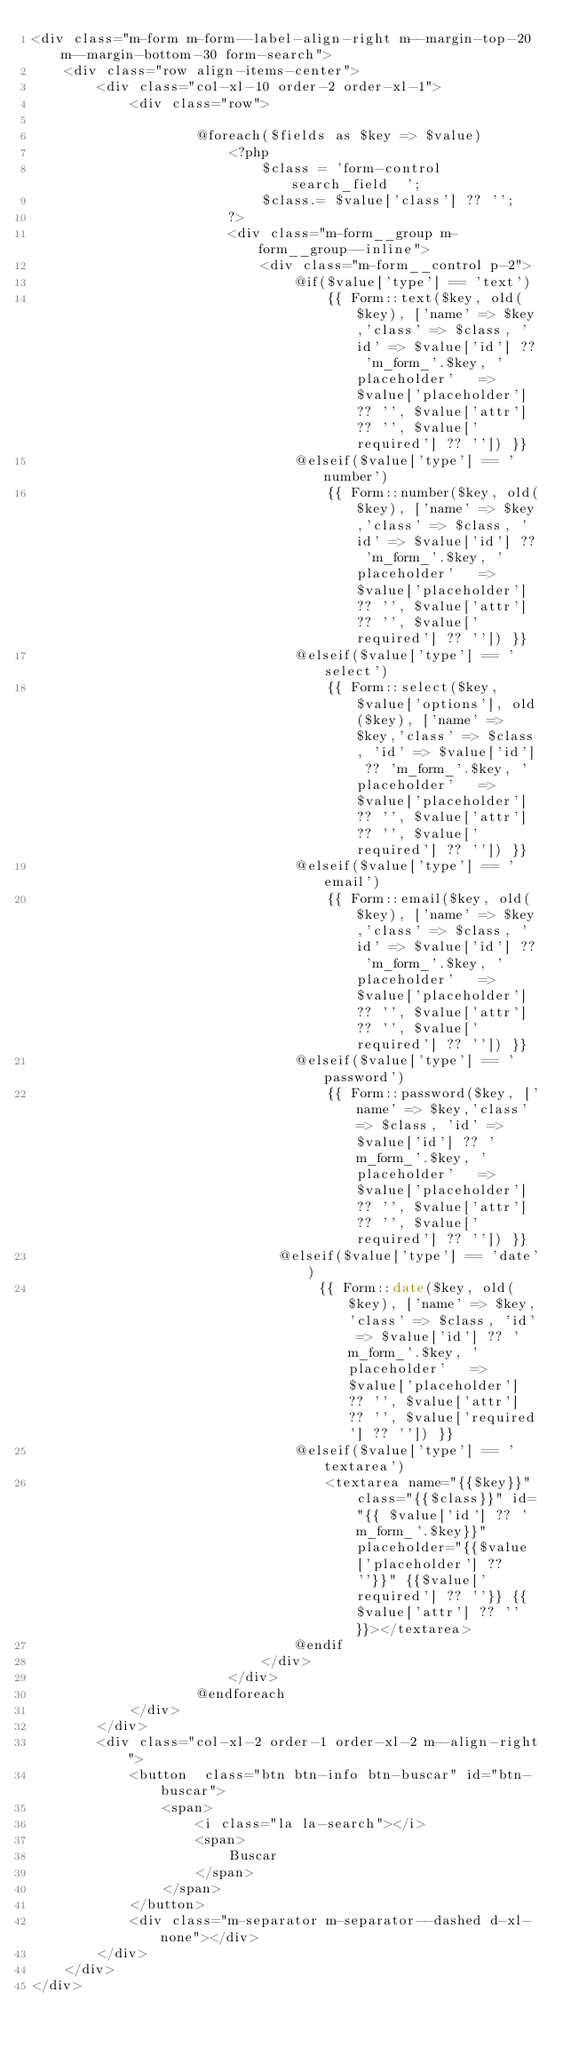Convert code to text. <code><loc_0><loc_0><loc_500><loc_500><_PHP_><div class="m-form m-form--label-align-right m--margin-top-20 m--margin-bottom-30 form-search">
    <div class="row align-items-center">
        <div class="col-xl-10 order-2 order-xl-1">
            <div class="row">

                    @foreach($fields as $key => $value)
                        <?php
                            $class = 'form-control search_field  ';
                            $class.= $value['class'] ?? '';
                        ?>
                        <div class="m-form__group m-form__group--inline">
                            <div class="m-form__control p-2">
                                @if($value['type'] == 'text')
                                    {{ Form::text($key, old($key), ['name' => $key,'class' => $class, 'id' => $value['id'] ?? 'm_form_'.$key, 'placeholder'   => $value['placeholder'] ?? '', $value['attr'] ?? '', $value['required'] ?? '']) }}
                                @elseif($value['type'] == 'number')
                                    {{ Form::number($key, old($key), ['name' => $key,'class' => $class, 'id' => $value['id'] ?? 'm_form_'.$key, 'placeholder'   => $value['placeholder'] ?? '', $value['attr'] ?? '', $value['required'] ?? '']) }}
                                @elseif($value['type'] == 'select')
                                    {{ Form::select($key, $value['options'], old($key), ['name' => $key,'class' => $class, 'id' => $value['id'] ?? 'm_form_'.$key, 'placeholder'   => $value['placeholder'] ?? '', $value['attr'] ?? '', $value['required'] ?? '']) }}
                                @elseif($value['type'] == 'email')
                                    {{ Form::email($key, old($key), ['name' => $key,'class' => $class, 'id' => $value['id'] ?? 'm_form_'.$key, 'placeholder'   => $value['placeholder'] ?? '', $value['attr'] ?? '', $value['required'] ?? '']) }}
                                @elseif($value['type'] == 'password')
                                    {{ Form::password($key, ['name' => $key,'class' => $class, 'id' => $value['id'] ?? 'm_form_'.$key, 'placeholder'   => $value['placeholder'] ?? '', $value['attr'] ?? '', $value['required'] ?? '']) }}
                              @elseif($value['type'] == 'date')
                                   {{ Form::date($key, old($key), ['name' => $key,'class' => $class, 'id' => $value['id'] ?? 'm_form_'.$key, 'placeholder'   => $value['placeholder'] ?? '', $value['attr'] ?? '', $value['required'] ?? '']) }}
                                @elseif($value['type'] == 'textarea')
                                    <textarea name="{{$key}}" class="{{$class}}" id="{{ $value['id'] ?? 'm_form_'.$key}}" placeholder="{{$value['placeholder'] ?? ''}}" {{$value['required'] ?? ''}} {{$value['attr'] ?? ''}}></textarea>
                                @endif
                            </div>
                        </div>
                    @endforeach
            </div>
        </div>
        <div class="col-xl-2 order-1 order-xl-2 m--align-right">
            <button  class="btn btn-info btn-buscar" id="btn-buscar">
                <span>
                    <i class="la la-search"></i>
                    <span>
                        Buscar
                    </span>
                </span>
            </button>
            <div class="m-separator m-separator--dashed d-xl-none"></div>
        </div>
    </div>
</div></code> 